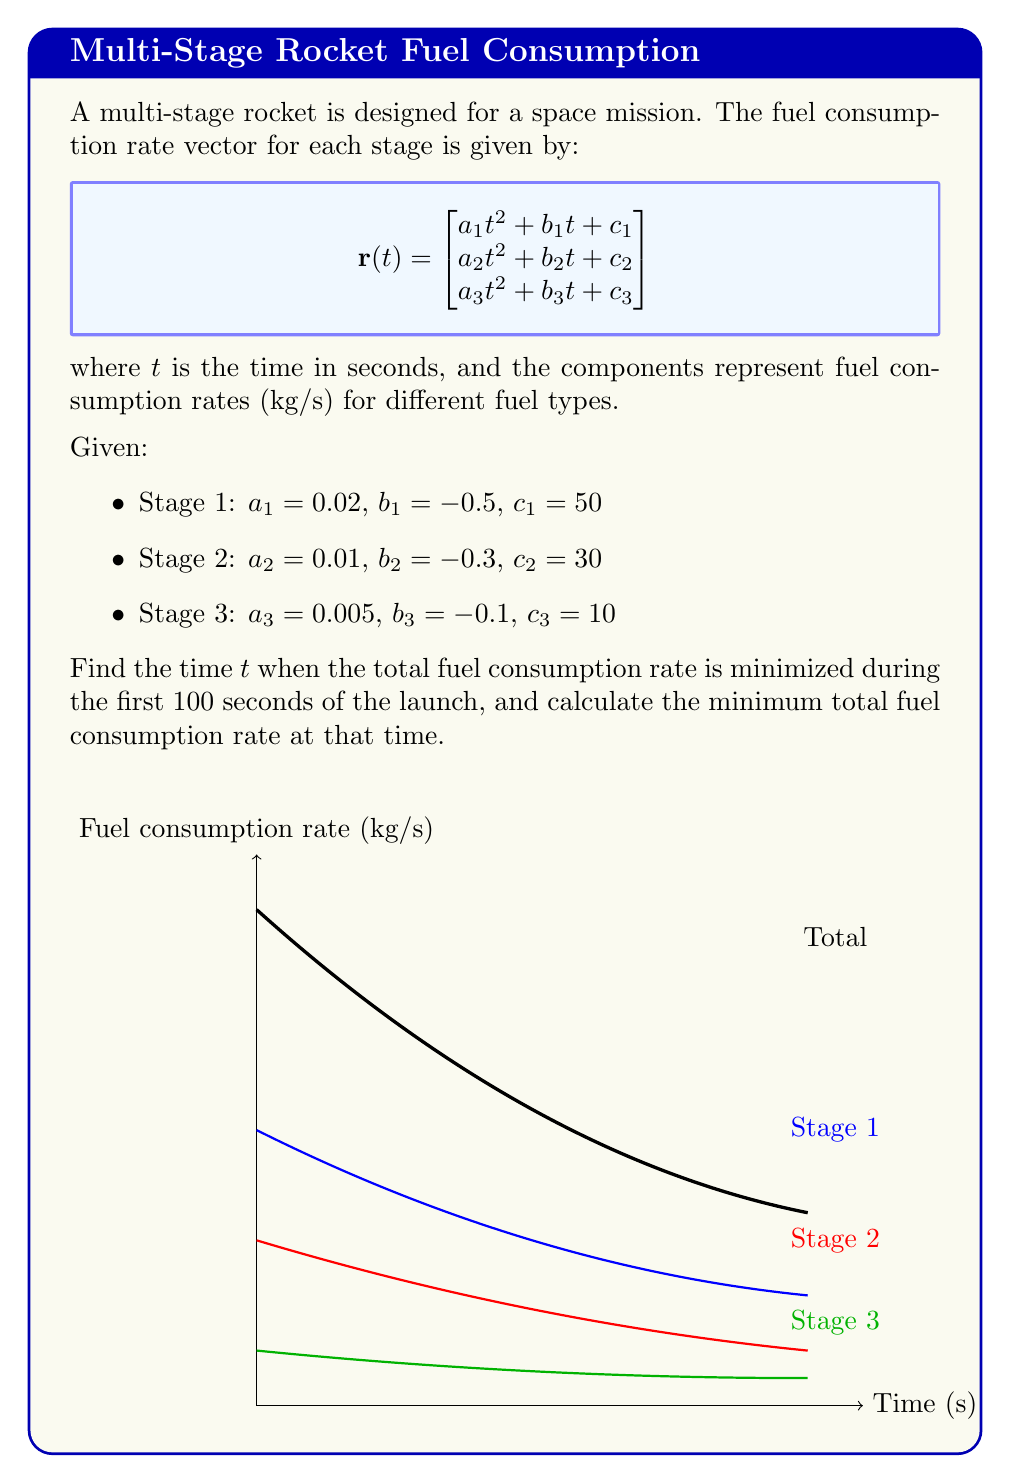What is the answer to this math problem? To solve this problem, we'll follow these steps:

1) First, we need to find the total fuel consumption rate by summing the components of the vector:

   $$r_{total}(t) = (0.02t^2 - 0.5t + 50) + (0.01t^2 - 0.3t + 30) + (0.005t^2 - 0.1t + 10)$$
   $$r_{total}(t) = 0.035t^2 - 0.9t + 90$$

2) To find the minimum of this function, we need to find where its derivative is zero:

   $$\frac{d}{dt}r_{total}(t) = 0.07t - 0.9$$

3) Set this equal to zero and solve for t:

   $$0.07t - 0.9 = 0$$
   $$0.07t = 0.9$$
   $$t = \frac{0.9}{0.07} \approx 12.86$$

4) We need to verify that this critical point is within our domain (0 to 100 seconds) and that it's a minimum, not a maximum. The second derivative is positive (0.07 > 0), confirming it's a minimum.

5) Now, we calculate the minimum total fuel consumption rate by plugging this t-value back into our $r_{total}(t)$ function:

   $$r_{total}(12.86) = 0.035(12.86)^2 - 0.9(12.86) + 90$$
   $$\approx 5.79 + (-11.57) + 90 = 84.22$$

Therefore, the minimum total fuel consumption rate occurs at approximately 12.86 seconds and is approximately 84.22 kg/s.
Answer: $t \approx 12.86$ s, $r_{min} \approx 84.22$ kg/s 